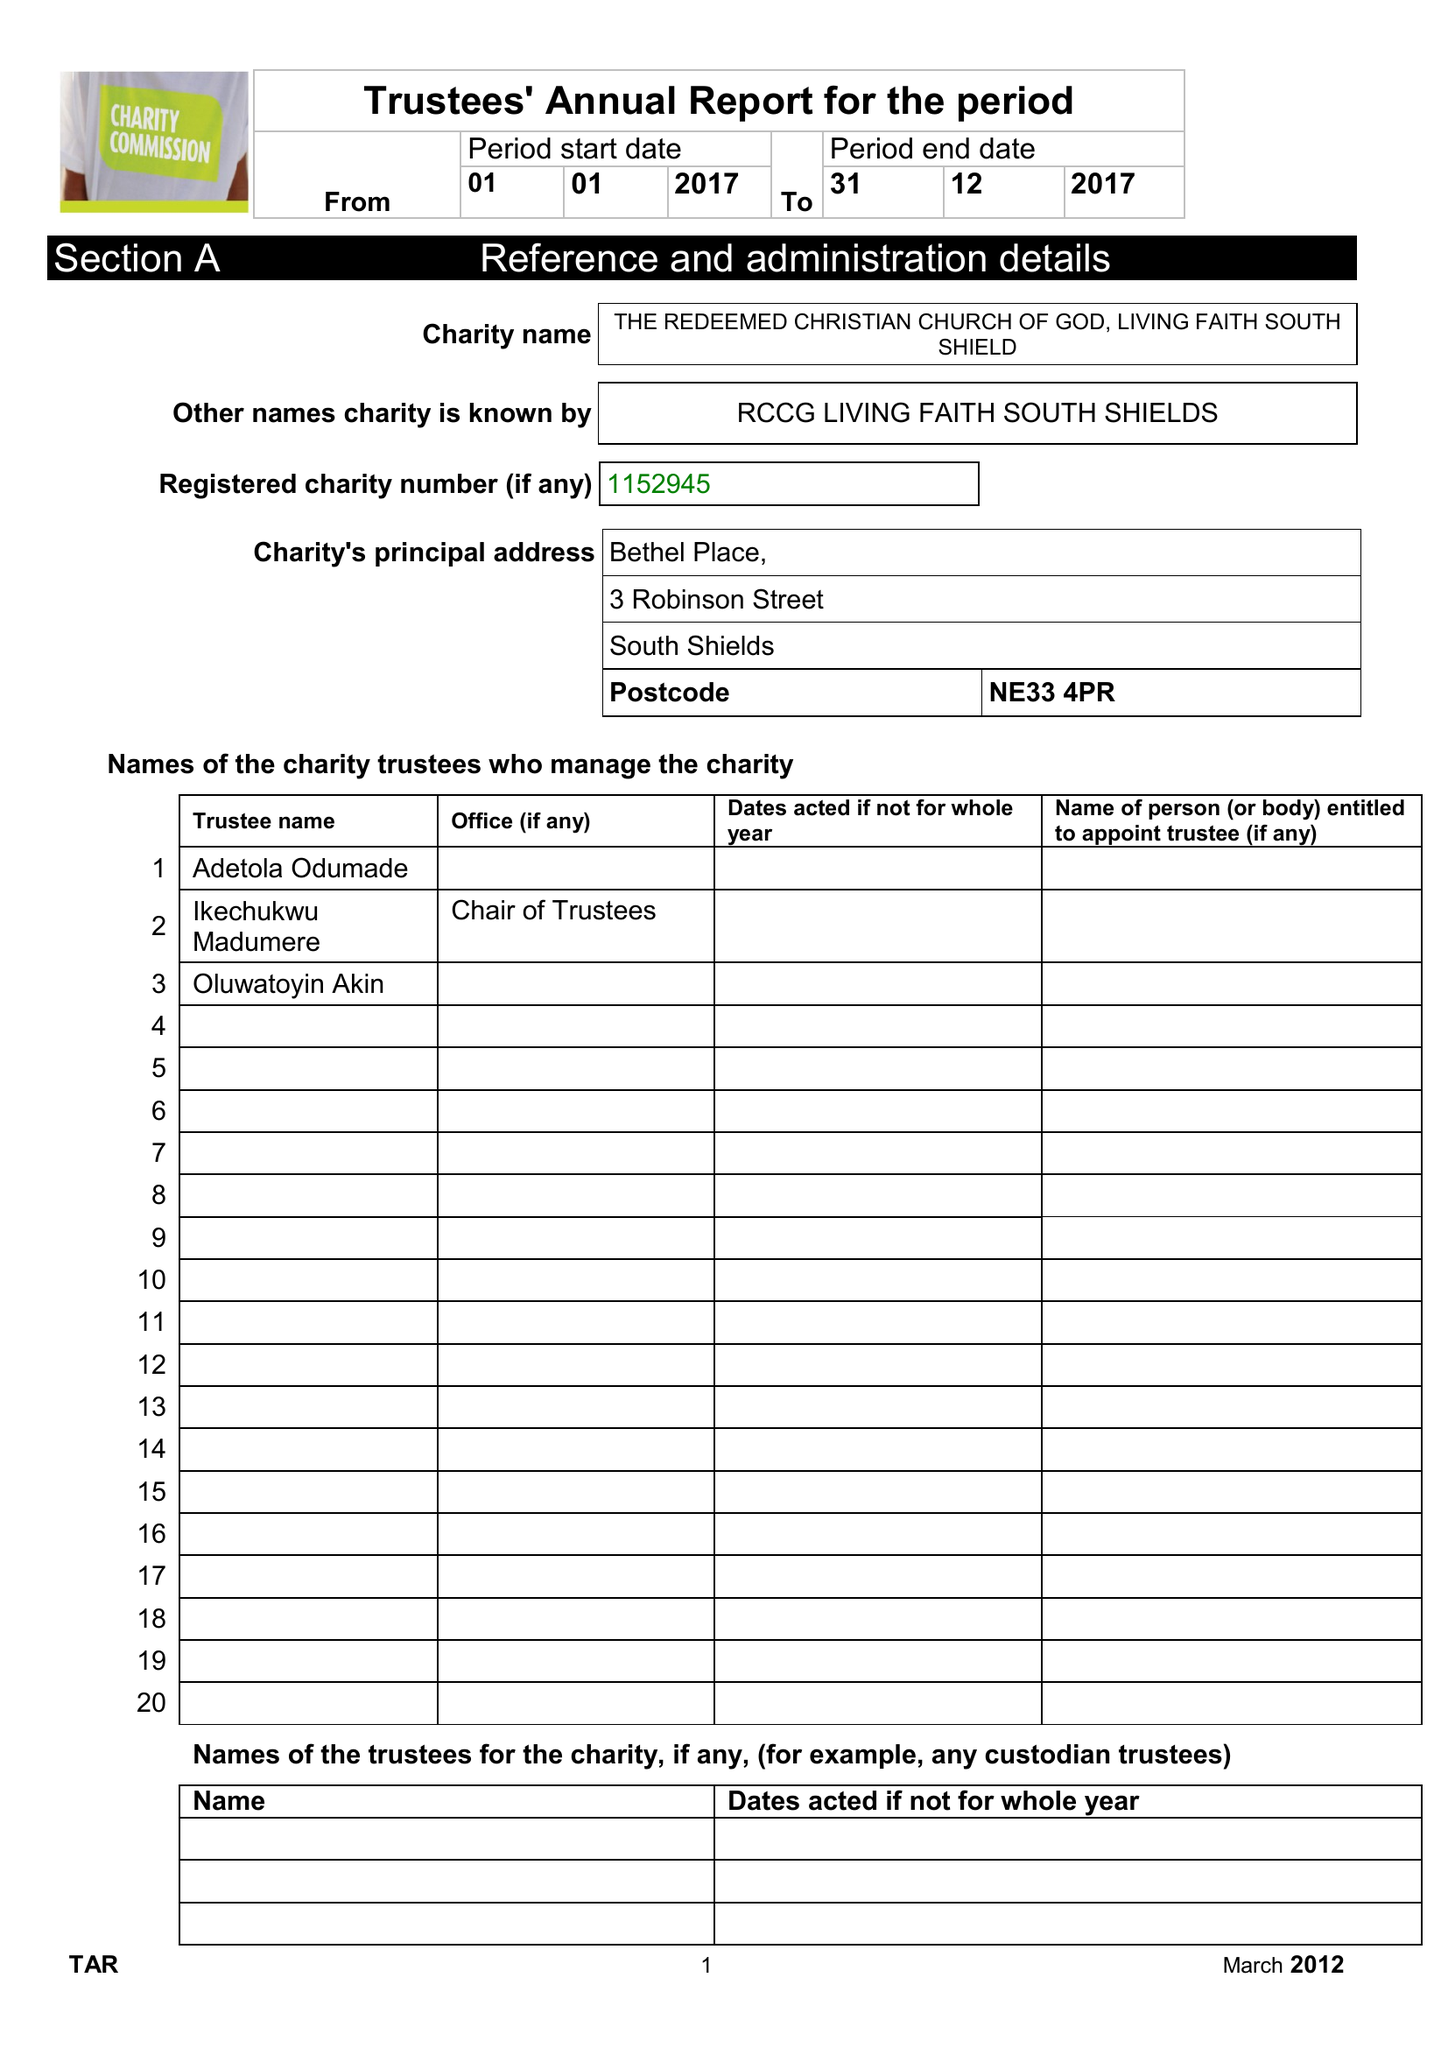What is the value for the spending_annually_in_british_pounds?
Answer the question using a single word or phrase. 25443.00 